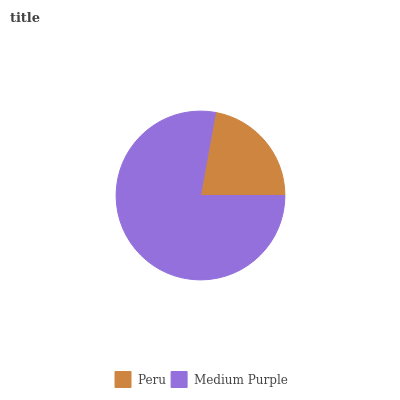Is Peru the minimum?
Answer yes or no. Yes. Is Medium Purple the maximum?
Answer yes or no. Yes. Is Medium Purple the minimum?
Answer yes or no. No. Is Medium Purple greater than Peru?
Answer yes or no. Yes. Is Peru less than Medium Purple?
Answer yes or no. Yes. Is Peru greater than Medium Purple?
Answer yes or no. No. Is Medium Purple less than Peru?
Answer yes or no. No. Is Medium Purple the high median?
Answer yes or no. Yes. Is Peru the low median?
Answer yes or no. Yes. Is Peru the high median?
Answer yes or no. No. Is Medium Purple the low median?
Answer yes or no. No. 